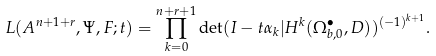<formula> <loc_0><loc_0><loc_500><loc_500>L ( { A } ^ { n + 1 + r } , \Psi , F ; t ) = \prod _ { k = 0 } ^ { n + r + 1 } \det ( I - t \alpha _ { k } | H ^ { k } ( \Omega _ { b , 0 } ^ { \bullet } , D ) ) ^ { ( - 1 ) ^ { k + 1 } } .</formula> 